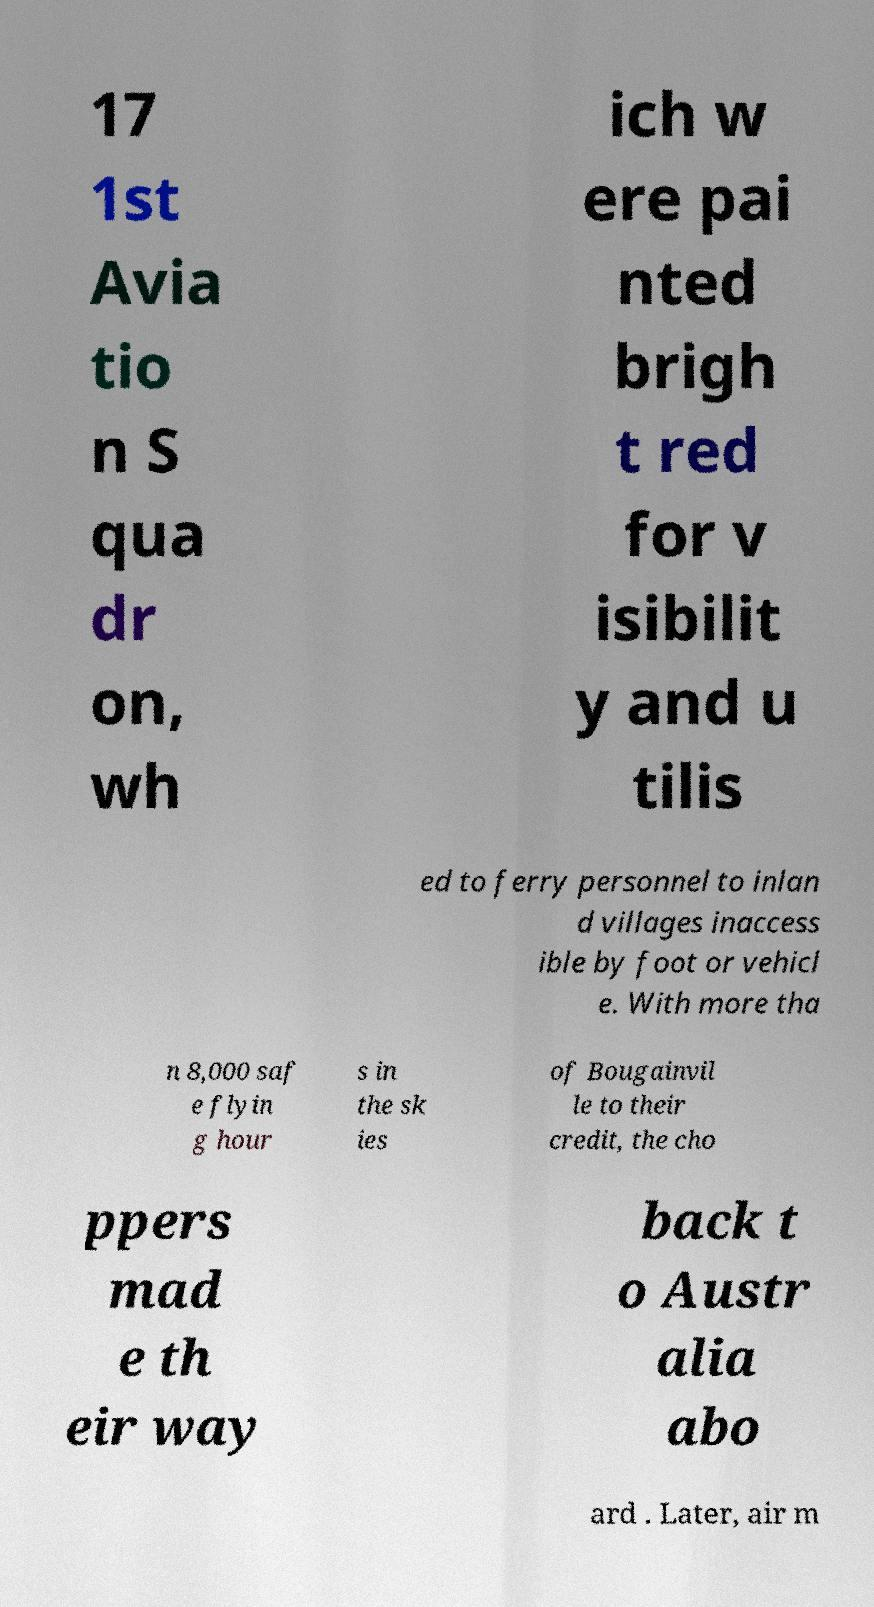Could you assist in decoding the text presented in this image and type it out clearly? 17 1st Avia tio n S qua dr on, wh ich w ere pai nted brigh t red for v isibilit y and u tilis ed to ferry personnel to inlan d villages inaccess ible by foot or vehicl e. With more tha n 8,000 saf e flyin g hour s in the sk ies of Bougainvil le to their credit, the cho ppers mad e th eir way back t o Austr alia abo ard . Later, air m 